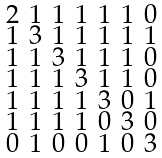Convert formula to latex. <formula><loc_0><loc_0><loc_500><loc_500>\begin{smallmatrix} 2 & 1 & 1 & 1 & 1 & 1 & 0 \\ 1 & 3 & 1 & 1 & 1 & 1 & 1 \\ 1 & 1 & 3 & 1 & 1 & 1 & 0 \\ 1 & 1 & 1 & 3 & 1 & 1 & 0 \\ 1 & 1 & 1 & 1 & 3 & 0 & 1 \\ 1 & 1 & 1 & 1 & 0 & 3 & 0 \\ 0 & 1 & 0 & 0 & 1 & 0 & 3 \end{smallmatrix}</formula> 